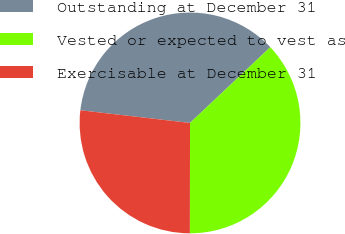Convert chart. <chart><loc_0><loc_0><loc_500><loc_500><pie_chart><fcel>Outstanding at December 31<fcel>Vested or expected to vest as<fcel>Exercisable at December 31<nl><fcel>36.13%<fcel>37.06%<fcel>26.81%<nl></chart> 